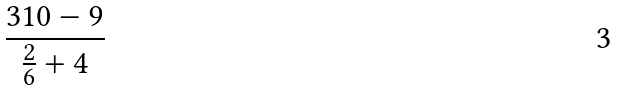Convert formula to latex. <formula><loc_0><loc_0><loc_500><loc_500>\frac { 3 1 0 - 9 } { \frac { 2 } { 6 } + 4 }</formula> 